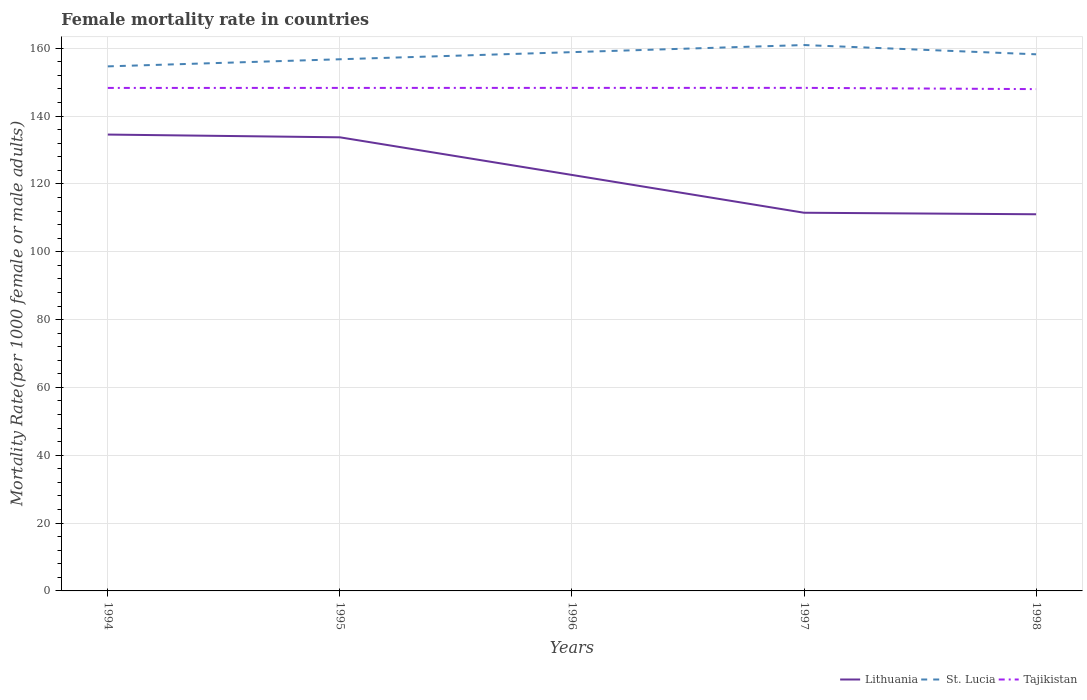How many different coloured lines are there?
Provide a succinct answer. 3. Does the line corresponding to St. Lucia intersect with the line corresponding to Tajikistan?
Offer a terse response. No. Across all years, what is the maximum female mortality rate in St. Lucia?
Offer a terse response. 154.66. What is the total female mortality rate in Tajikistan in the graph?
Your answer should be very brief. 0.35. What is the difference between the highest and the second highest female mortality rate in Lithuania?
Provide a succinct answer. 23.5. What is the difference between two consecutive major ticks on the Y-axis?
Offer a terse response. 20. Where does the legend appear in the graph?
Make the answer very short. Bottom right. How many legend labels are there?
Ensure brevity in your answer.  3. How are the legend labels stacked?
Provide a short and direct response. Horizontal. What is the title of the graph?
Your answer should be compact. Female mortality rate in countries. Does "Latvia" appear as one of the legend labels in the graph?
Your answer should be compact. No. What is the label or title of the X-axis?
Provide a short and direct response. Years. What is the label or title of the Y-axis?
Give a very brief answer. Mortality Rate(per 1000 female or male adults). What is the Mortality Rate(per 1000 female or male adults) in Lithuania in 1994?
Offer a terse response. 134.55. What is the Mortality Rate(per 1000 female or male adults) in St. Lucia in 1994?
Give a very brief answer. 154.66. What is the Mortality Rate(per 1000 female or male adults) of Tajikistan in 1994?
Ensure brevity in your answer.  148.3. What is the Mortality Rate(per 1000 female or male adults) in Lithuania in 1995?
Provide a short and direct response. 133.74. What is the Mortality Rate(per 1000 female or male adults) of St. Lucia in 1995?
Give a very brief answer. 156.75. What is the Mortality Rate(per 1000 female or male adults) in Tajikistan in 1995?
Your response must be concise. 148.31. What is the Mortality Rate(per 1000 female or male adults) in Lithuania in 1996?
Ensure brevity in your answer.  122.65. What is the Mortality Rate(per 1000 female or male adults) of St. Lucia in 1996?
Your answer should be compact. 158.85. What is the Mortality Rate(per 1000 female or male adults) of Tajikistan in 1996?
Provide a succinct answer. 148.32. What is the Mortality Rate(per 1000 female or male adults) of Lithuania in 1997?
Offer a very short reply. 111.5. What is the Mortality Rate(per 1000 female or male adults) in St. Lucia in 1997?
Your response must be concise. 160.95. What is the Mortality Rate(per 1000 female or male adults) of Tajikistan in 1997?
Your response must be concise. 148.32. What is the Mortality Rate(per 1000 female or male adults) in Lithuania in 1998?
Make the answer very short. 111.05. What is the Mortality Rate(per 1000 female or male adults) of St. Lucia in 1998?
Make the answer very short. 158.22. What is the Mortality Rate(per 1000 female or male adults) in Tajikistan in 1998?
Provide a short and direct response. 147.95. Across all years, what is the maximum Mortality Rate(per 1000 female or male adults) in Lithuania?
Give a very brief answer. 134.55. Across all years, what is the maximum Mortality Rate(per 1000 female or male adults) in St. Lucia?
Provide a short and direct response. 160.95. Across all years, what is the maximum Mortality Rate(per 1000 female or male adults) of Tajikistan?
Your response must be concise. 148.32. Across all years, what is the minimum Mortality Rate(per 1000 female or male adults) in Lithuania?
Your answer should be compact. 111.05. Across all years, what is the minimum Mortality Rate(per 1000 female or male adults) of St. Lucia?
Make the answer very short. 154.66. Across all years, what is the minimum Mortality Rate(per 1000 female or male adults) of Tajikistan?
Make the answer very short. 147.95. What is the total Mortality Rate(per 1000 female or male adults) of Lithuania in the graph?
Ensure brevity in your answer.  613.5. What is the total Mortality Rate(per 1000 female or male adults) of St. Lucia in the graph?
Offer a very short reply. 789.43. What is the total Mortality Rate(per 1000 female or male adults) of Tajikistan in the graph?
Make the answer very short. 741.21. What is the difference between the Mortality Rate(per 1000 female or male adults) in Lithuania in 1994 and that in 1995?
Your answer should be very brief. 0.81. What is the difference between the Mortality Rate(per 1000 female or male adults) in St. Lucia in 1994 and that in 1995?
Your answer should be compact. -2.1. What is the difference between the Mortality Rate(per 1000 female or male adults) of Tajikistan in 1994 and that in 1995?
Provide a succinct answer. -0.01. What is the difference between the Mortality Rate(per 1000 female or male adults) in Lithuania in 1994 and that in 1996?
Provide a short and direct response. 11.9. What is the difference between the Mortality Rate(per 1000 female or male adults) in St. Lucia in 1994 and that in 1996?
Make the answer very short. -4.19. What is the difference between the Mortality Rate(per 1000 female or male adults) in Tajikistan in 1994 and that in 1996?
Provide a succinct answer. -0.01. What is the difference between the Mortality Rate(per 1000 female or male adults) of Lithuania in 1994 and that in 1997?
Give a very brief answer. 23.05. What is the difference between the Mortality Rate(per 1000 female or male adults) in St. Lucia in 1994 and that in 1997?
Provide a short and direct response. -6.29. What is the difference between the Mortality Rate(per 1000 female or male adults) in Tajikistan in 1994 and that in 1997?
Provide a short and direct response. -0.02. What is the difference between the Mortality Rate(per 1000 female or male adults) of Lithuania in 1994 and that in 1998?
Your answer should be very brief. 23.5. What is the difference between the Mortality Rate(per 1000 female or male adults) of St. Lucia in 1994 and that in 1998?
Offer a very short reply. -3.56. What is the difference between the Mortality Rate(per 1000 female or male adults) in Tajikistan in 1994 and that in 1998?
Your response must be concise. 0.35. What is the difference between the Mortality Rate(per 1000 female or male adults) of Lithuania in 1995 and that in 1996?
Provide a short and direct response. 11.1. What is the difference between the Mortality Rate(per 1000 female or male adults) in St. Lucia in 1995 and that in 1996?
Keep it short and to the point. -2.1. What is the difference between the Mortality Rate(per 1000 female or male adults) of Tajikistan in 1995 and that in 1996?
Your response must be concise. -0.01. What is the difference between the Mortality Rate(per 1000 female or male adults) of Lithuania in 1995 and that in 1997?
Offer a terse response. 22.24. What is the difference between the Mortality Rate(per 1000 female or male adults) in St. Lucia in 1995 and that in 1997?
Give a very brief answer. -4.19. What is the difference between the Mortality Rate(per 1000 female or male adults) in Tajikistan in 1995 and that in 1997?
Keep it short and to the point. -0.01. What is the difference between the Mortality Rate(per 1000 female or male adults) of Lithuania in 1995 and that in 1998?
Your answer should be very brief. 22.69. What is the difference between the Mortality Rate(per 1000 female or male adults) of St. Lucia in 1995 and that in 1998?
Provide a short and direct response. -1.46. What is the difference between the Mortality Rate(per 1000 female or male adults) of Tajikistan in 1995 and that in 1998?
Give a very brief answer. 0.36. What is the difference between the Mortality Rate(per 1000 female or male adults) in Lithuania in 1996 and that in 1997?
Keep it short and to the point. 11.14. What is the difference between the Mortality Rate(per 1000 female or male adults) of St. Lucia in 1996 and that in 1997?
Give a very brief answer. -2.1. What is the difference between the Mortality Rate(per 1000 female or male adults) of Tajikistan in 1996 and that in 1997?
Your answer should be compact. -0.01. What is the difference between the Mortality Rate(per 1000 female or male adults) in Lithuania in 1996 and that in 1998?
Offer a terse response. 11.59. What is the difference between the Mortality Rate(per 1000 female or male adults) of St. Lucia in 1996 and that in 1998?
Offer a very short reply. 0.64. What is the difference between the Mortality Rate(per 1000 female or male adults) of Tajikistan in 1996 and that in 1998?
Make the answer very short. 0.36. What is the difference between the Mortality Rate(per 1000 female or male adults) in Lithuania in 1997 and that in 1998?
Offer a very short reply. 0.45. What is the difference between the Mortality Rate(per 1000 female or male adults) in St. Lucia in 1997 and that in 1998?
Provide a short and direct response. 2.73. What is the difference between the Mortality Rate(per 1000 female or male adults) in Tajikistan in 1997 and that in 1998?
Your answer should be compact. 0.37. What is the difference between the Mortality Rate(per 1000 female or male adults) in Lithuania in 1994 and the Mortality Rate(per 1000 female or male adults) in St. Lucia in 1995?
Offer a terse response. -22.2. What is the difference between the Mortality Rate(per 1000 female or male adults) of Lithuania in 1994 and the Mortality Rate(per 1000 female or male adults) of Tajikistan in 1995?
Offer a very short reply. -13.76. What is the difference between the Mortality Rate(per 1000 female or male adults) of St. Lucia in 1994 and the Mortality Rate(per 1000 female or male adults) of Tajikistan in 1995?
Provide a succinct answer. 6.35. What is the difference between the Mortality Rate(per 1000 female or male adults) in Lithuania in 1994 and the Mortality Rate(per 1000 female or male adults) in St. Lucia in 1996?
Keep it short and to the point. -24.3. What is the difference between the Mortality Rate(per 1000 female or male adults) of Lithuania in 1994 and the Mortality Rate(per 1000 female or male adults) of Tajikistan in 1996?
Provide a short and direct response. -13.77. What is the difference between the Mortality Rate(per 1000 female or male adults) in St. Lucia in 1994 and the Mortality Rate(per 1000 female or male adults) in Tajikistan in 1996?
Provide a succinct answer. 6.34. What is the difference between the Mortality Rate(per 1000 female or male adults) in Lithuania in 1994 and the Mortality Rate(per 1000 female or male adults) in St. Lucia in 1997?
Your answer should be compact. -26.4. What is the difference between the Mortality Rate(per 1000 female or male adults) of Lithuania in 1994 and the Mortality Rate(per 1000 female or male adults) of Tajikistan in 1997?
Provide a short and direct response. -13.77. What is the difference between the Mortality Rate(per 1000 female or male adults) of St. Lucia in 1994 and the Mortality Rate(per 1000 female or male adults) of Tajikistan in 1997?
Your response must be concise. 6.33. What is the difference between the Mortality Rate(per 1000 female or male adults) of Lithuania in 1994 and the Mortality Rate(per 1000 female or male adults) of St. Lucia in 1998?
Your answer should be very brief. -23.67. What is the difference between the Mortality Rate(per 1000 female or male adults) in Lithuania in 1994 and the Mortality Rate(per 1000 female or male adults) in Tajikistan in 1998?
Your response must be concise. -13.4. What is the difference between the Mortality Rate(per 1000 female or male adults) of St. Lucia in 1994 and the Mortality Rate(per 1000 female or male adults) of Tajikistan in 1998?
Offer a terse response. 6.71. What is the difference between the Mortality Rate(per 1000 female or male adults) of Lithuania in 1995 and the Mortality Rate(per 1000 female or male adults) of St. Lucia in 1996?
Offer a terse response. -25.11. What is the difference between the Mortality Rate(per 1000 female or male adults) of Lithuania in 1995 and the Mortality Rate(per 1000 female or male adults) of Tajikistan in 1996?
Your answer should be compact. -14.57. What is the difference between the Mortality Rate(per 1000 female or male adults) in St. Lucia in 1995 and the Mortality Rate(per 1000 female or male adults) in Tajikistan in 1996?
Keep it short and to the point. 8.44. What is the difference between the Mortality Rate(per 1000 female or male adults) of Lithuania in 1995 and the Mortality Rate(per 1000 female or male adults) of St. Lucia in 1997?
Ensure brevity in your answer.  -27.21. What is the difference between the Mortality Rate(per 1000 female or male adults) in Lithuania in 1995 and the Mortality Rate(per 1000 female or male adults) in Tajikistan in 1997?
Provide a succinct answer. -14.58. What is the difference between the Mortality Rate(per 1000 female or male adults) in St. Lucia in 1995 and the Mortality Rate(per 1000 female or male adults) in Tajikistan in 1997?
Your response must be concise. 8.43. What is the difference between the Mortality Rate(per 1000 female or male adults) in Lithuania in 1995 and the Mortality Rate(per 1000 female or male adults) in St. Lucia in 1998?
Ensure brevity in your answer.  -24.48. What is the difference between the Mortality Rate(per 1000 female or male adults) in Lithuania in 1995 and the Mortality Rate(per 1000 female or male adults) in Tajikistan in 1998?
Your answer should be compact. -14.21. What is the difference between the Mortality Rate(per 1000 female or male adults) of St. Lucia in 1995 and the Mortality Rate(per 1000 female or male adults) of Tajikistan in 1998?
Your answer should be very brief. 8.8. What is the difference between the Mortality Rate(per 1000 female or male adults) in Lithuania in 1996 and the Mortality Rate(per 1000 female or male adults) in St. Lucia in 1997?
Keep it short and to the point. -38.3. What is the difference between the Mortality Rate(per 1000 female or male adults) of Lithuania in 1996 and the Mortality Rate(per 1000 female or male adults) of Tajikistan in 1997?
Your answer should be compact. -25.68. What is the difference between the Mortality Rate(per 1000 female or male adults) of St. Lucia in 1996 and the Mortality Rate(per 1000 female or male adults) of Tajikistan in 1997?
Give a very brief answer. 10.53. What is the difference between the Mortality Rate(per 1000 female or male adults) in Lithuania in 1996 and the Mortality Rate(per 1000 female or male adults) in St. Lucia in 1998?
Ensure brevity in your answer.  -35.57. What is the difference between the Mortality Rate(per 1000 female or male adults) in Lithuania in 1996 and the Mortality Rate(per 1000 female or male adults) in Tajikistan in 1998?
Provide a short and direct response. -25.31. What is the difference between the Mortality Rate(per 1000 female or male adults) in St. Lucia in 1996 and the Mortality Rate(per 1000 female or male adults) in Tajikistan in 1998?
Provide a succinct answer. 10.9. What is the difference between the Mortality Rate(per 1000 female or male adults) in Lithuania in 1997 and the Mortality Rate(per 1000 female or male adults) in St. Lucia in 1998?
Ensure brevity in your answer.  -46.71. What is the difference between the Mortality Rate(per 1000 female or male adults) of Lithuania in 1997 and the Mortality Rate(per 1000 female or male adults) of Tajikistan in 1998?
Your answer should be compact. -36.45. What is the difference between the Mortality Rate(per 1000 female or male adults) of St. Lucia in 1997 and the Mortality Rate(per 1000 female or male adults) of Tajikistan in 1998?
Offer a terse response. 13. What is the average Mortality Rate(per 1000 female or male adults) in Lithuania per year?
Provide a short and direct response. 122.7. What is the average Mortality Rate(per 1000 female or male adults) in St. Lucia per year?
Provide a short and direct response. 157.89. What is the average Mortality Rate(per 1000 female or male adults) in Tajikistan per year?
Your answer should be compact. 148.24. In the year 1994, what is the difference between the Mortality Rate(per 1000 female or male adults) in Lithuania and Mortality Rate(per 1000 female or male adults) in St. Lucia?
Offer a very short reply. -20.11. In the year 1994, what is the difference between the Mortality Rate(per 1000 female or male adults) in Lithuania and Mortality Rate(per 1000 female or male adults) in Tajikistan?
Your response must be concise. -13.75. In the year 1994, what is the difference between the Mortality Rate(per 1000 female or male adults) of St. Lucia and Mortality Rate(per 1000 female or male adults) of Tajikistan?
Provide a short and direct response. 6.36. In the year 1995, what is the difference between the Mortality Rate(per 1000 female or male adults) of Lithuania and Mortality Rate(per 1000 female or male adults) of St. Lucia?
Ensure brevity in your answer.  -23.01. In the year 1995, what is the difference between the Mortality Rate(per 1000 female or male adults) of Lithuania and Mortality Rate(per 1000 female or male adults) of Tajikistan?
Give a very brief answer. -14.57. In the year 1995, what is the difference between the Mortality Rate(per 1000 female or male adults) of St. Lucia and Mortality Rate(per 1000 female or male adults) of Tajikistan?
Provide a succinct answer. 8.45. In the year 1996, what is the difference between the Mortality Rate(per 1000 female or male adults) in Lithuania and Mortality Rate(per 1000 female or male adults) in St. Lucia?
Your response must be concise. -36.21. In the year 1996, what is the difference between the Mortality Rate(per 1000 female or male adults) in Lithuania and Mortality Rate(per 1000 female or male adults) in Tajikistan?
Your response must be concise. -25.67. In the year 1996, what is the difference between the Mortality Rate(per 1000 female or male adults) of St. Lucia and Mortality Rate(per 1000 female or male adults) of Tajikistan?
Provide a succinct answer. 10.54. In the year 1997, what is the difference between the Mortality Rate(per 1000 female or male adults) in Lithuania and Mortality Rate(per 1000 female or male adults) in St. Lucia?
Provide a succinct answer. -49.45. In the year 1997, what is the difference between the Mortality Rate(per 1000 female or male adults) of Lithuania and Mortality Rate(per 1000 female or male adults) of Tajikistan?
Offer a terse response. -36.82. In the year 1997, what is the difference between the Mortality Rate(per 1000 female or male adults) in St. Lucia and Mortality Rate(per 1000 female or male adults) in Tajikistan?
Keep it short and to the point. 12.62. In the year 1998, what is the difference between the Mortality Rate(per 1000 female or male adults) in Lithuania and Mortality Rate(per 1000 female or male adults) in St. Lucia?
Ensure brevity in your answer.  -47.16. In the year 1998, what is the difference between the Mortality Rate(per 1000 female or male adults) in Lithuania and Mortality Rate(per 1000 female or male adults) in Tajikistan?
Provide a succinct answer. -36.9. In the year 1998, what is the difference between the Mortality Rate(per 1000 female or male adults) in St. Lucia and Mortality Rate(per 1000 female or male adults) in Tajikistan?
Provide a succinct answer. 10.27. What is the ratio of the Mortality Rate(per 1000 female or male adults) of St. Lucia in 1994 to that in 1995?
Provide a short and direct response. 0.99. What is the ratio of the Mortality Rate(per 1000 female or male adults) of Tajikistan in 1994 to that in 1995?
Keep it short and to the point. 1. What is the ratio of the Mortality Rate(per 1000 female or male adults) of Lithuania in 1994 to that in 1996?
Offer a terse response. 1.1. What is the ratio of the Mortality Rate(per 1000 female or male adults) in St. Lucia in 1994 to that in 1996?
Offer a very short reply. 0.97. What is the ratio of the Mortality Rate(per 1000 female or male adults) in Lithuania in 1994 to that in 1997?
Ensure brevity in your answer.  1.21. What is the ratio of the Mortality Rate(per 1000 female or male adults) in St. Lucia in 1994 to that in 1997?
Provide a succinct answer. 0.96. What is the ratio of the Mortality Rate(per 1000 female or male adults) of Lithuania in 1994 to that in 1998?
Your response must be concise. 1.21. What is the ratio of the Mortality Rate(per 1000 female or male adults) in St. Lucia in 1994 to that in 1998?
Provide a succinct answer. 0.98. What is the ratio of the Mortality Rate(per 1000 female or male adults) of Lithuania in 1995 to that in 1996?
Offer a terse response. 1.09. What is the ratio of the Mortality Rate(per 1000 female or male adults) of Lithuania in 1995 to that in 1997?
Keep it short and to the point. 1.2. What is the ratio of the Mortality Rate(per 1000 female or male adults) of St. Lucia in 1995 to that in 1997?
Give a very brief answer. 0.97. What is the ratio of the Mortality Rate(per 1000 female or male adults) in Tajikistan in 1995 to that in 1997?
Offer a very short reply. 1. What is the ratio of the Mortality Rate(per 1000 female or male adults) of Lithuania in 1995 to that in 1998?
Your answer should be very brief. 1.2. What is the ratio of the Mortality Rate(per 1000 female or male adults) of St. Lucia in 1995 to that in 1998?
Offer a very short reply. 0.99. What is the ratio of the Mortality Rate(per 1000 female or male adults) in Tajikistan in 1995 to that in 1998?
Your answer should be compact. 1. What is the ratio of the Mortality Rate(per 1000 female or male adults) of Lithuania in 1996 to that in 1997?
Your response must be concise. 1.1. What is the ratio of the Mortality Rate(per 1000 female or male adults) in St. Lucia in 1996 to that in 1997?
Offer a very short reply. 0.99. What is the ratio of the Mortality Rate(per 1000 female or male adults) in Tajikistan in 1996 to that in 1997?
Provide a short and direct response. 1. What is the ratio of the Mortality Rate(per 1000 female or male adults) in Lithuania in 1996 to that in 1998?
Give a very brief answer. 1.1. What is the ratio of the Mortality Rate(per 1000 female or male adults) of Tajikistan in 1996 to that in 1998?
Make the answer very short. 1. What is the ratio of the Mortality Rate(per 1000 female or male adults) in Lithuania in 1997 to that in 1998?
Offer a terse response. 1. What is the ratio of the Mortality Rate(per 1000 female or male adults) of St. Lucia in 1997 to that in 1998?
Offer a very short reply. 1.02. What is the ratio of the Mortality Rate(per 1000 female or male adults) of Tajikistan in 1997 to that in 1998?
Offer a terse response. 1. What is the difference between the highest and the second highest Mortality Rate(per 1000 female or male adults) in Lithuania?
Offer a terse response. 0.81. What is the difference between the highest and the second highest Mortality Rate(per 1000 female or male adults) in St. Lucia?
Your response must be concise. 2.1. What is the difference between the highest and the second highest Mortality Rate(per 1000 female or male adults) of Tajikistan?
Keep it short and to the point. 0.01. What is the difference between the highest and the lowest Mortality Rate(per 1000 female or male adults) in Lithuania?
Your response must be concise. 23.5. What is the difference between the highest and the lowest Mortality Rate(per 1000 female or male adults) of St. Lucia?
Provide a short and direct response. 6.29. What is the difference between the highest and the lowest Mortality Rate(per 1000 female or male adults) in Tajikistan?
Your answer should be very brief. 0.37. 